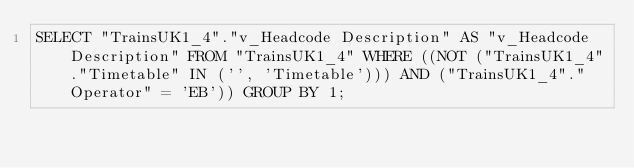<code> <loc_0><loc_0><loc_500><loc_500><_SQL_>SELECT "TrainsUK1_4"."v_Headcode Description" AS "v_Headcode Description" FROM "TrainsUK1_4" WHERE ((NOT ("TrainsUK1_4"."Timetable" IN ('', 'Timetable'))) AND ("TrainsUK1_4"."Operator" = 'EB')) GROUP BY 1;
</code> 